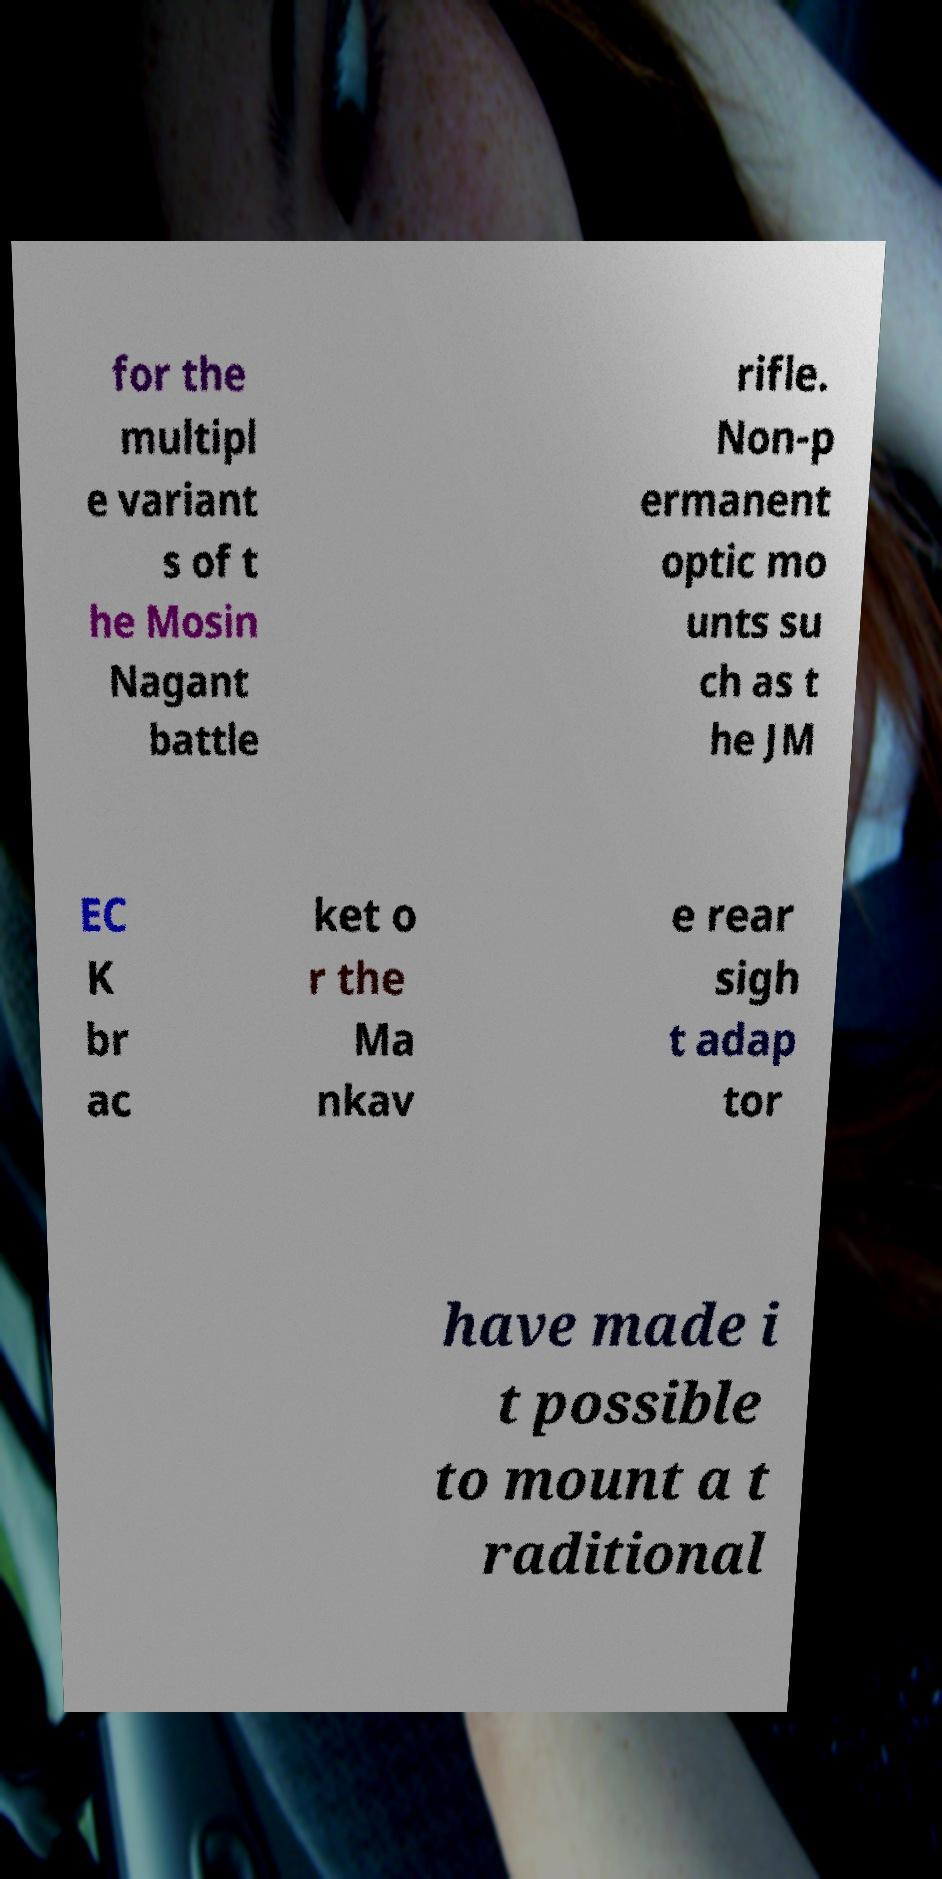There's text embedded in this image that I need extracted. Can you transcribe it verbatim? for the multipl e variant s of t he Mosin Nagant battle rifle. Non-p ermanent optic mo unts su ch as t he JM EC K br ac ket o r the Ma nkav e rear sigh t adap tor have made i t possible to mount a t raditional 